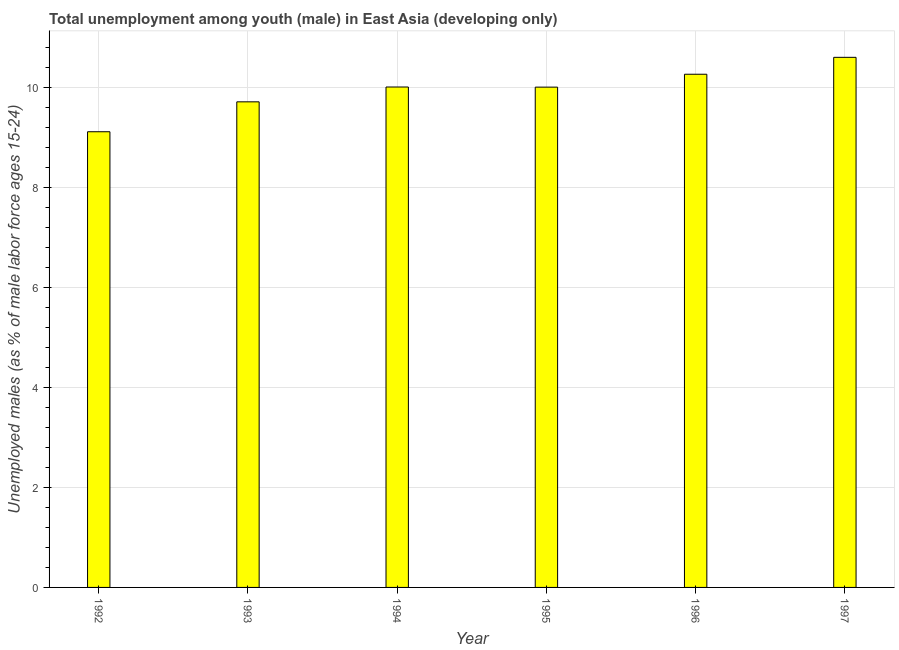Does the graph contain any zero values?
Keep it short and to the point. No. What is the title of the graph?
Provide a short and direct response. Total unemployment among youth (male) in East Asia (developing only). What is the label or title of the X-axis?
Offer a very short reply. Year. What is the label or title of the Y-axis?
Keep it short and to the point. Unemployed males (as % of male labor force ages 15-24). What is the unemployed male youth population in 1994?
Your response must be concise. 10.01. Across all years, what is the maximum unemployed male youth population?
Your answer should be very brief. 10.6. Across all years, what is the minimum unemployed male youth population?
Your answer should be very brief. 9.11. In which year was the unemployed male youth population maximum?
Keep it short and to the point. 1997. What is the sum of the unemployed male youth population?
Offer a terse response. 59.7. What is the difference between the unemployed male youth population in 1994 and 1995?
Make the answer very short. 0. What is the average unemployed male youth population per year?
Give a very brief answer. 9.95. What is the median unemployed male youth population?
Provide a succinct answer. 10.01. In how many years, is the unemployed male youth population greater than 0.4 %?
Offer a terse response. 6. What is the ratio of the unemployed male youth population in 1994 to that in 1997?
Provide a succinct answer. 0.94. What is the difference between the highest and the second highest unemployed male youth population?
Your answer should be compact. 0.34. What is the difference between the highest and the lowest unemployed male youth population?
Provide a short and direct response. 1.49. In how many years, is the unemployed male youth population greater than the average unemployed male youth population taken over all years?
Ensure brevity in your answer.  4. What is the difference between two consecutive major ticks on the Y-axis?
Offer a terse response. 2. What is the Unemployed males (as % of male labor force ages 15-24) of 1992?
Your answer should be very brief. 9.11. What is the Unemployed males (as % of male labor force ages 15-24) in 1993?
Offer a terse response. 9.71. What is the Unemployed males (as % of male labor force ages 15-24) of 1994?
Provide a short and direct response. 10.01. What is the Unemployed males (as % of male labor force ages 15-24) of 1995?
Offer a very short reply. 10. What is the Unemployed males (as % of male labor force ages 15-24) of 1996?
Keep it short and to the point. 10.26. What is the Unemployed males (as % of male labor force ages 15-24) of 1997?
Your answer should be compact. 10.6. What is the difference between the Unemployed males (as % of male labor force ages 15-24) in 1992 and 1993?
Your response must be concise. -0.6. What is the difference between the Unemployed males (as % of male labor force ages 15-24) in 1992 and 1994?
Give a very brief answer. -0.89. What is the difference between the Unemployed males (as % of male labor force ages 15-24) in 1992 and 1995?
Keep it short and to the point. -0.89. What is the difference between the Unemployed males (as % of male labor force ages 15-24) in 1992 and 1996?
Offer a very short reply. -1.15. What is the difference between the Unemployed males (as % of male labor force ages 15-24) in 1992 and 1997?
Offer a terse response. -1.49. What is the difference between the Unemployed males (as % of male labor force ages 15-24) in 1993 and 1994?
Your answer should be very brief. -0.3. What is the difference between the Unemployed males (as % of male labor force ages 15-24) in 1993 and 1995?
Offer a very short reply. -0.29. What is the difference between the Unemployed males (as % of male labor force ages 15-24) in 1993 and 1996?
Make the answer very short. -0.55. What is the difference between the Unemployed males (as % of male labor force ages 15-24) in 1993 and 1997?
Keep it short and to the point. -0.89. What is the difference between the Unemployed males (as % of male labor force ages 15-24) in 1994 and 1995?
Your answer should be very brief. 0. What is the difference between the Unemployed males (as % of male labor force ages 15-24) in 1994 and 1996?
Provide a succinct answer. -0.26. What is the difference between the Unemployed males (as % of male labor force ages 15-24) in 1994 and 1997?
Your answer should be compact. -0.59. What is the difference between the Unemployed males (as % of male labor force ages 15-24) in 1995 and 1996?
Your answer should be very brief. -0.26. What is the difference between the Unemployed males (as % of male labor force ages 15-24) in 1995 and 1997?
Your response must be concise. -0.6. What is the difference between the Unemployed males (as % of male labor force ages 15-24) in 1996 and 1997?
Your answer should be compact. -0.34. What is the ratio of the Unemployed males (as % of male labor force ages 15-24) in 1992 to that in 1993?
Offer a terse response. 0.94. What is the ratio of the Unemployed males (as % of male labor force ages 15-24) in 1992 to that in 1994?
Keep it short and to the point. 0.91. What is the ratio of the Unemployed males (as % of male labor force ages 15-24) in 1992 to that in 1995?
Offer a very short reply. 0.91. What is the ratio of the Unemployed males (as % of male labor force ages 15-24) in 1992 to that in 1996?
Make the answer very short. 0.89. What is the ratio of the Unemployed males (as % of male labor force ages 15-24) in 1992 to that in 1997?
Make the answer very short. 0.86. What is the ratio of the Unemployed males (as % of male labor force ages 15-24) in 1993 to that in 1995?
Give a very brief answer. 0.97. What is the ratio of the Unemployed males (as % of male labor force ages 15-24) in 1993 to that in 1996?
Offer a very short reply. 0.95. What is the ratio of the Unemployed males (as % of male labor force ages 15-24) in 1993 to that in 1997?
Your answer should be compact. 0.92. What is the ratio of the Unemployed males (as % of male labor force ages 15-24) in 1994 to that in 1997?
Your answer should be compact. 0.94. What is the ratio of the Unemployed males (as % of male labor force ages 15-24) in 1995 to that in 1996?
Offer a terse response. 0.97. What is the ratio of the Unemployed males (as % of male labor force ages 15-24) in 1995 to that in 1997?
Give a very brief answer. 0.94. What is the ratio of the Unemployed males (as % of male labor force ages 15-24) in 1996 to that in 1997?
Keep it short and to the point. 0.97. 